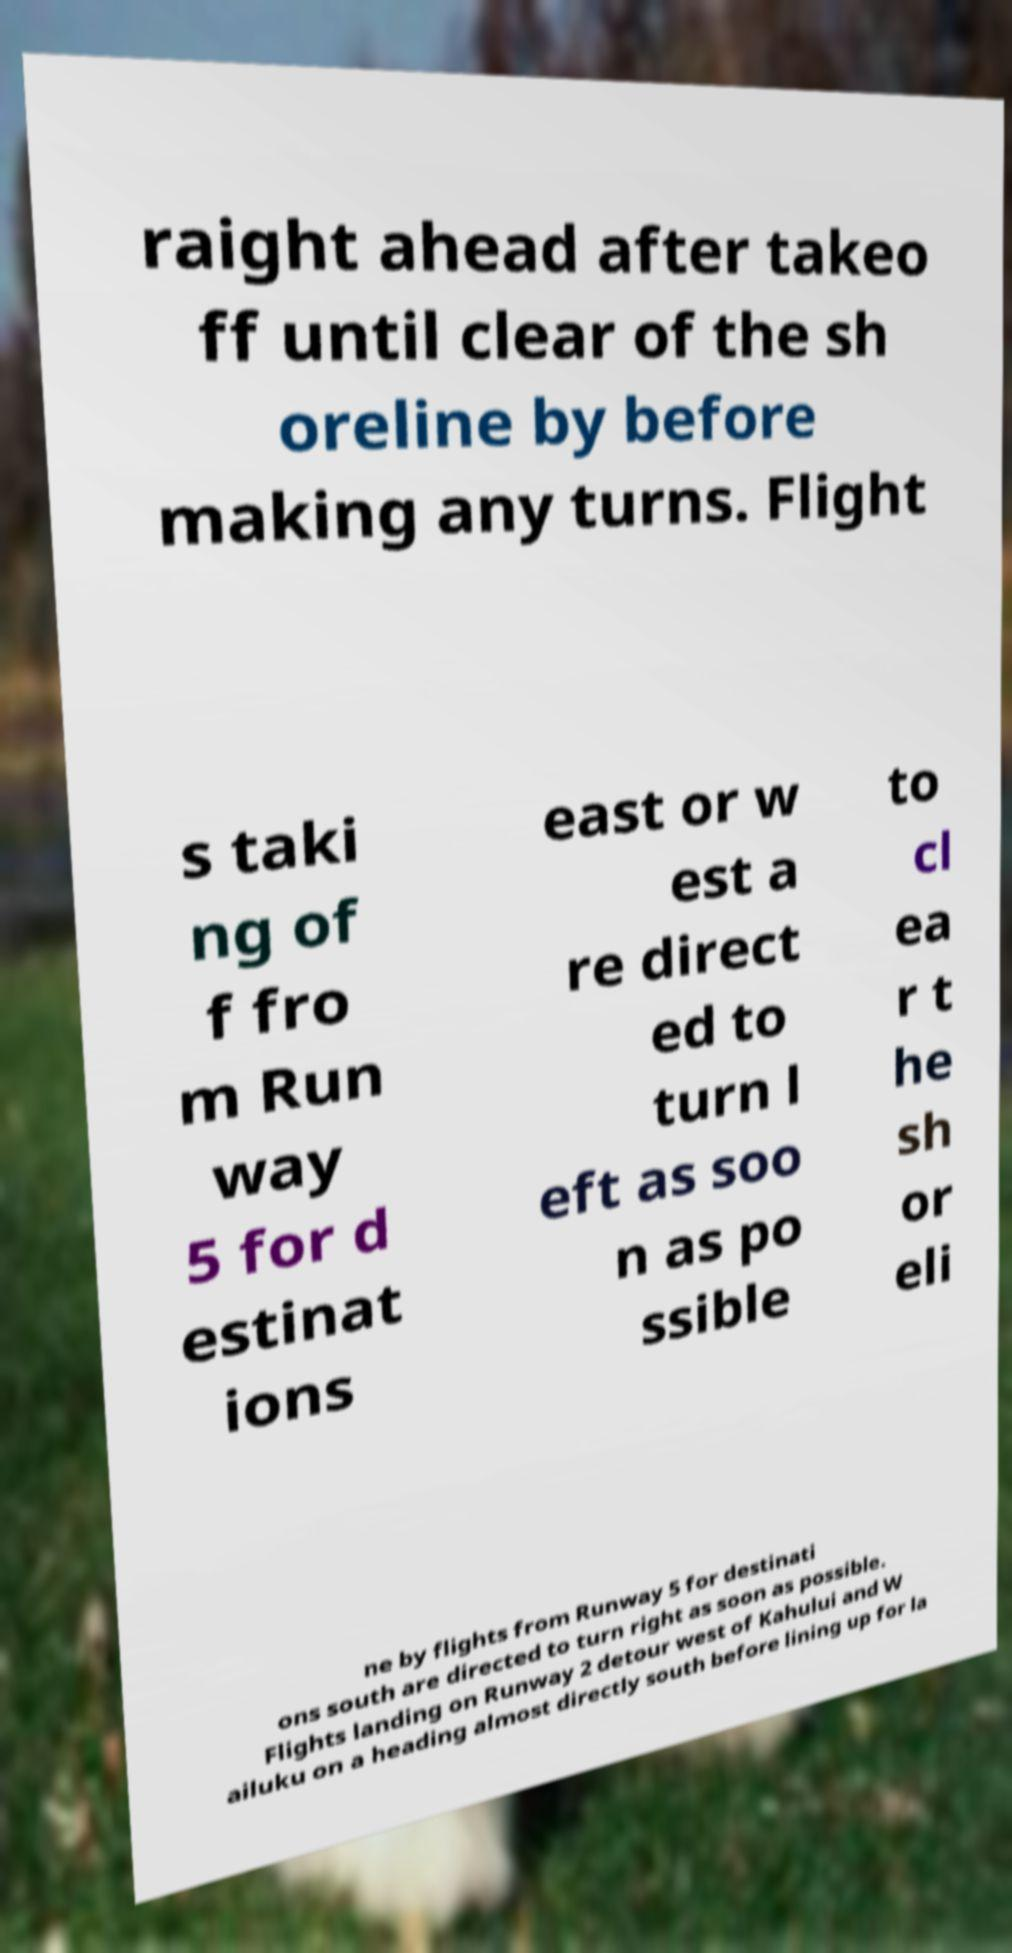What messages or text are displayed in this image? I need them in a readable, typed format. raight ahead after takeo ff until clear of the sh oreline by before making any turns. Flight s taki ng of f fro m Run way 5 for d estinat ions east or w est a re direct ed to turn l eft as soo n as po ssible to cl ea r t he sh or eli ne by flights from Runway 5 for destinati ons south are directed to turn right as soon as possible. Flights landing on Runway 2 detour west of Kahului and W ailuku on a heading almost directly south before lining up for la 